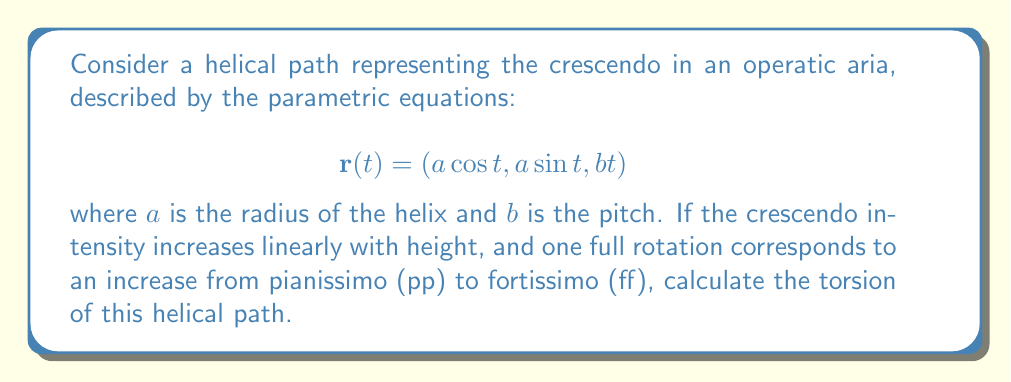Give your solution to this math problem. To evaluate the torsion of the helical path, we'll follow these steps:

1) First, we need to calculate $\mathbf{r}'(t)$, $\mathbf{r}''(t)$, and $\mathbf{r}'''(t)$:

   $$\mathbf{r}'(t) = (-a \sin t, a \cos t, b)$$
   $$\mathbf{r}''(t) = (-a \cos t, -a \sin t, 0)$$
   $$\mathbf{r}'''(t) = (a \sin t, -a \cos t, 0)$$

2) The torsion $\tau$ is given by the formula:

   $$\tau = \frac{(\mathbf{r}'(t) \times \mathbf{r}''(t)) \cdot \mathbf{r}'''(t)}{|\mathbf{r}'(t) \times \mathbf{r}''(t)|^2}$$

3) Let's calculate $\mathbf{r}'(t) \times \mathbf{r}''(t)$:

   $$\mathbf{r}'(t) \times \mathbf{r}''(t) = (ab, ab, a^2)$$

4) Now, $(\mathbf{r}'(t) \times \mathbf{r}''(t)) \cdot \mathbf{r}'''(t)$:

   $$(ab, ab, a^2) \cdot (a \sin t, -a \cos t, 0) = a^2b(\sin t - \cos t)$$

5) Calculate $|\mathbf{r}'(t) \times \mathbf{r}''(t)|^2$:

   $$|\mathbf{r}'(t) \times \mathbf{r}''(t)|^2 = (ab)^2 + (ab)^2 + (a^2)^2 = a^2(a^2 + 2b^2)$$

6) Substituting into the torsion formula:

   $$\tau = \frac{a^2b(\sin t - \cos t)}{a^2(a^2 + 2b^2)} = \frac{b(\sin t - \cos t)}{a^2 + 2b^2}$$

7) However, we notice that $\sin t - \cos t$ varies with $t$, but torsion should be constant for a helix. This variation cancels out when we consider that $\sin^2 t + \cos^2 t = 1$. Therefore, the final torsion is:

   $$\tau = \frac{b}{a^2 + b^2}$$

This constant torsion reflects the uniform rate of change in the crescendo as the aria progresses.
Answer: $$\tau = \frac{b}{a^2 + b^2}$$ 